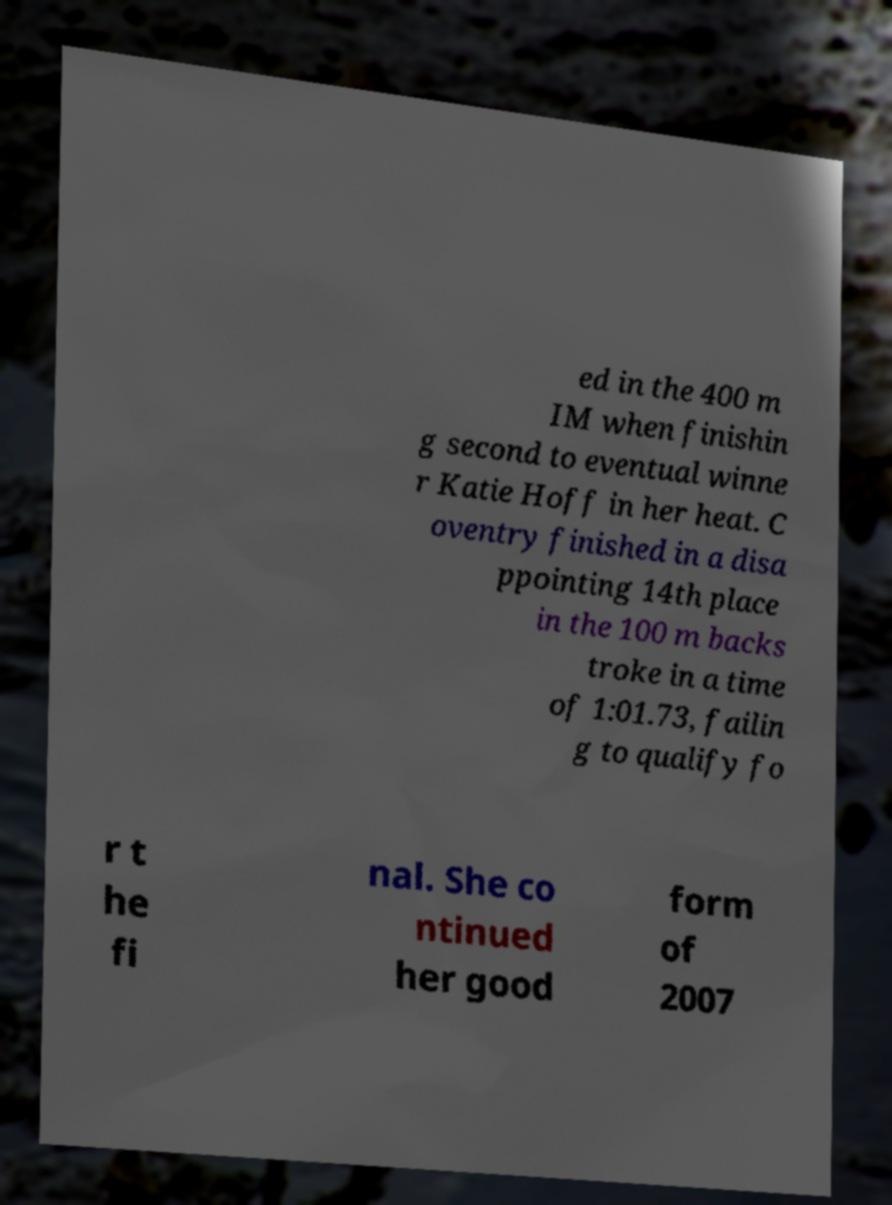Please identify and transcribe the text found in this image. ed in the 400 m IM when finishin g second to eventual winne r Katie Hoff in her heat. C oventry finished in a disa ppointing 14th place in the 100 m backs troke in a time of 1:01.73, failin g to qualify fo r t he fi nal. She co ntinued her good form of 2007 